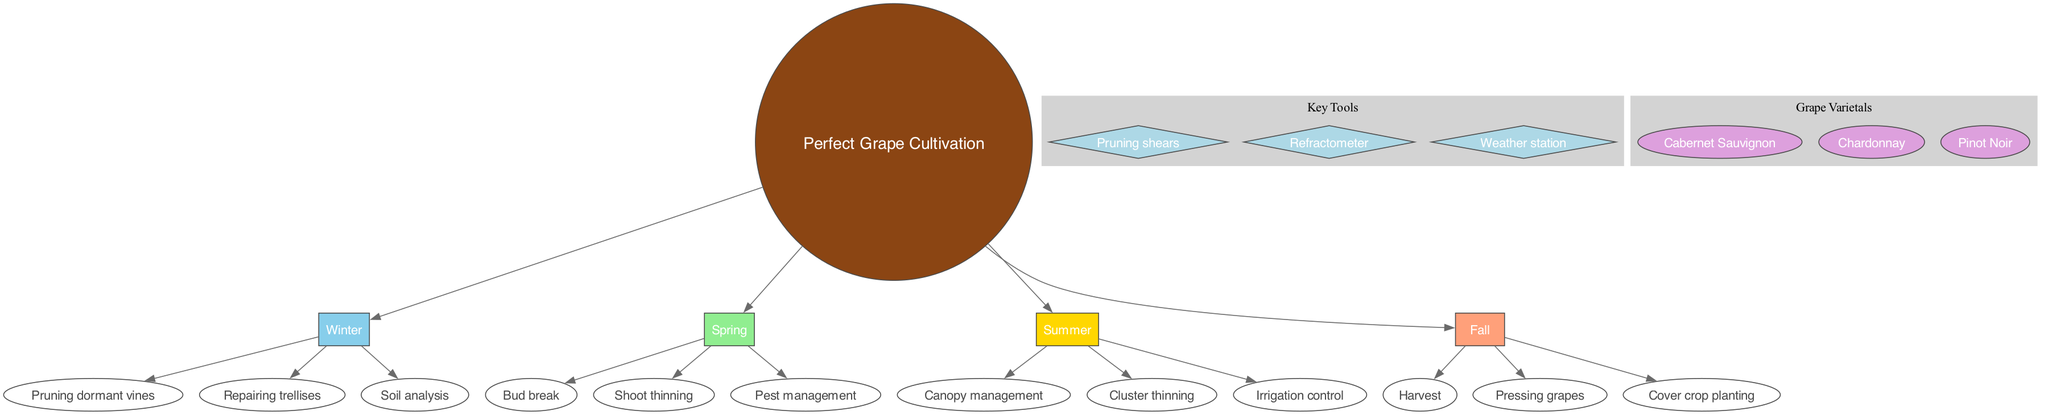What activities are performed in Winter? Winter includes three activities: pruning dormant vines, repairing trellises, and soil analysis. You can find these activities listed directly under the Winter season node in the diagram.
Answer: Pruning dormant vines, repairing trellises, soil analysis How many activities are listed for Spring? Spring has three specific activities associated with it: bud break, shoot thinning, and pest management. Counting these activities provides the answer to the question.
Answer: 3 What is the color associated with Summer? The Summer season in the diagram is represented with the color gold, which is typically shown in the corresponding node. This information is straightforward as each season has a designated color.
Answer: Gold Which season contains the activity "Harvest"? The activity "Harvest" is specifically assigned to the Fall season in the diagram. This can be confirmed by checking the activities under the Fall season node.
Answer: Fall What is the shape of the nodes used for activities? The activity nodes are represented by ellipse-shaped nodes in the diagram. This information can be directly observed from the graphical representation and node descriptions.
Answer: Ellipse How many grape varietals are featured in the diagram? The diagram lists three distinct grape varietals under the grape varietals section. Counting these provides the required answer to the question.
Answer: 3 Which key tool is used for measuring grape sugar levels? The refractometer is the key tool specifically mentioned for measuring grape sugar levels. This is confirmed directly from the key tools section within the diagram.
Answer: Refractometer What color represents the Winter season? In the diagram, Winter is represented by a light blue color. This visualization can be verified by looking at the node that corresponds to Winter.
Answer: Light blue Which activity is performed in Summer that helps manage water supply? The activity related to water supply management performed during Summer is irrigation control. This is detailed under the Summer activities node in the diagram.
Answer: Irrigation control 